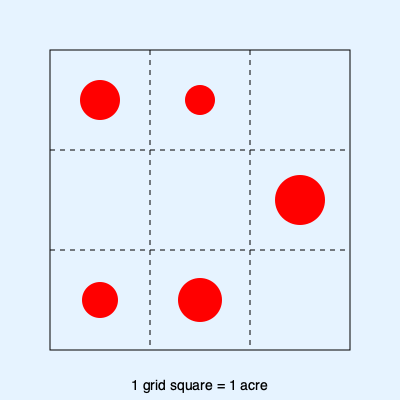A local forest area has been divided into a 3x3 grid for monitoring the spread of an invasive plant species. Each grid square represents 1 acre. Red circles indicate infected areas, with their size roughly proportional to the severity of the infection. Estimate the total infected area in acres, rounding to the nearest whole number. To estimate the total infected area, we'll follow these steps:

1. Assess each grid square's infection level:
   - Top-left: About 25% infected
   - Top-middle: About 15% infected
   - Top-right: No visible infection
   - Middle-left: No visible infection
   - Middle-center: No visible infection
   - Middle-right: About 50% infected
   - Bottom-left: About 20% infected
   - Bottom-center: About 40% infected
   - Bottom-right: No visible infection

2. Sum up the percentages:
   $25\% + 15\% + 0\% + 0\% + 0\% + 50\% + 20\% + 40\% + 0\% = 150\%$

3. Convert to acres:
   $150\% = 1.5$ acres

4. Round to the nearest whole number:
   $1.5$ rounded to the nearest whole number is $2$

Therefore, the estimated total infected area is 2 acres.
Answer: 2 acres 